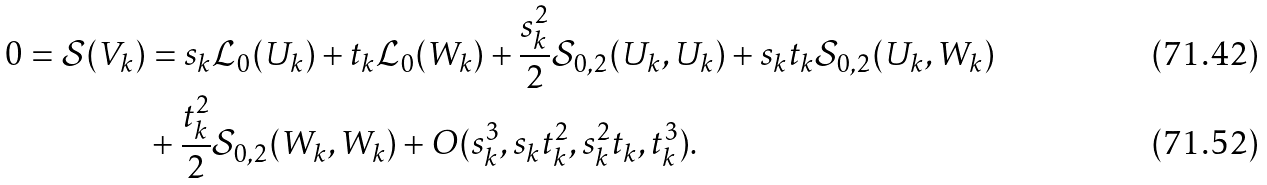Convert formula to latex. <formula><loc_0><loc_0><loc_500><loc_500>0 = \mathcal { S } ( V _ { k } ) & = s _ { k } \mathcal { L } _ { 0 } ( U _ { k } ) + t _ { k } \mathcal { L } _ { 0 } ( W _ { k } ) + \frac { s _ { k } ^ { 2 } } { 2 } \mathcal { S } _ { 0 , 2 } ( U _ { k } , U _ { k } ) + s _ { k } t _ { k } \mathcal { S } _ { 0 , 2 } ( U _ { k } , W _ { k } ) \\ & + \frac { t _ { k } ^ { 2 } } { 2 } \mathcal { S } _ { 0 , 2 } ( W _ { k } , W _ { k } ) + O ( s _ { k } ^ { 3 } , s _ { k } t _ { k } ^ { 2 } , s _ { k } ^ { 2 } t _ { k } , t _ { k } ^ { 3 } ) .</formula> 